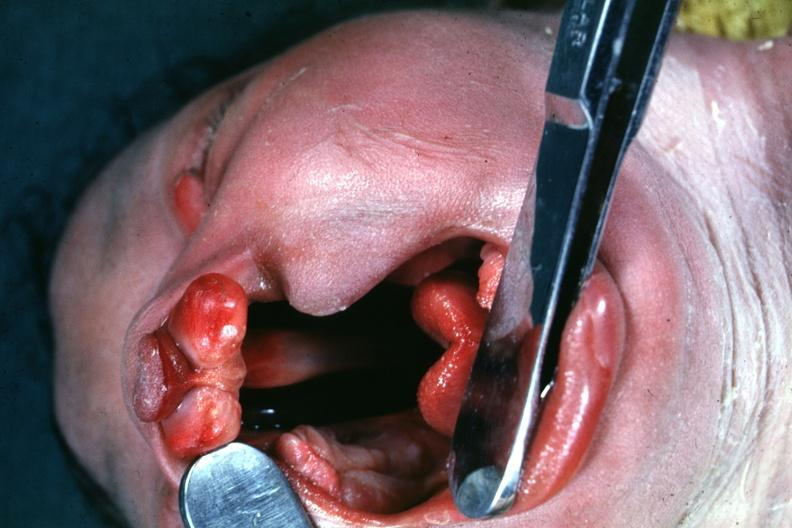how does this image show head tilted?
Answer the question using a single word or phrase. With mouth 